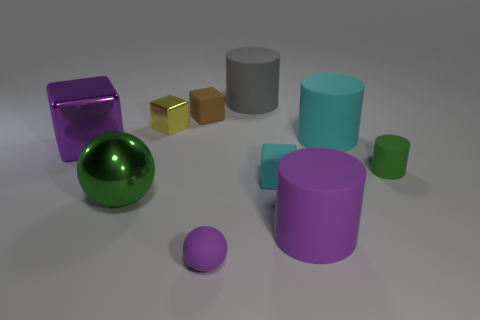Can you describe the shapes and their arrangement in the image? Sure, the image displays a variety of geometric shapes neatly arranged on a flat surface. There's a large purple cylinder on the right, next to a smaller version of a similar shade. A reflective green sphere and a small purple sphere also catch the eye. In the center, we see two small cubes, one gold and one bronze, placed closely together. A medium-sized grey cylinder is located slightly to their left. Altogether, these objects seem carefully placed, likely to illustrate differences in size, color, and material. 